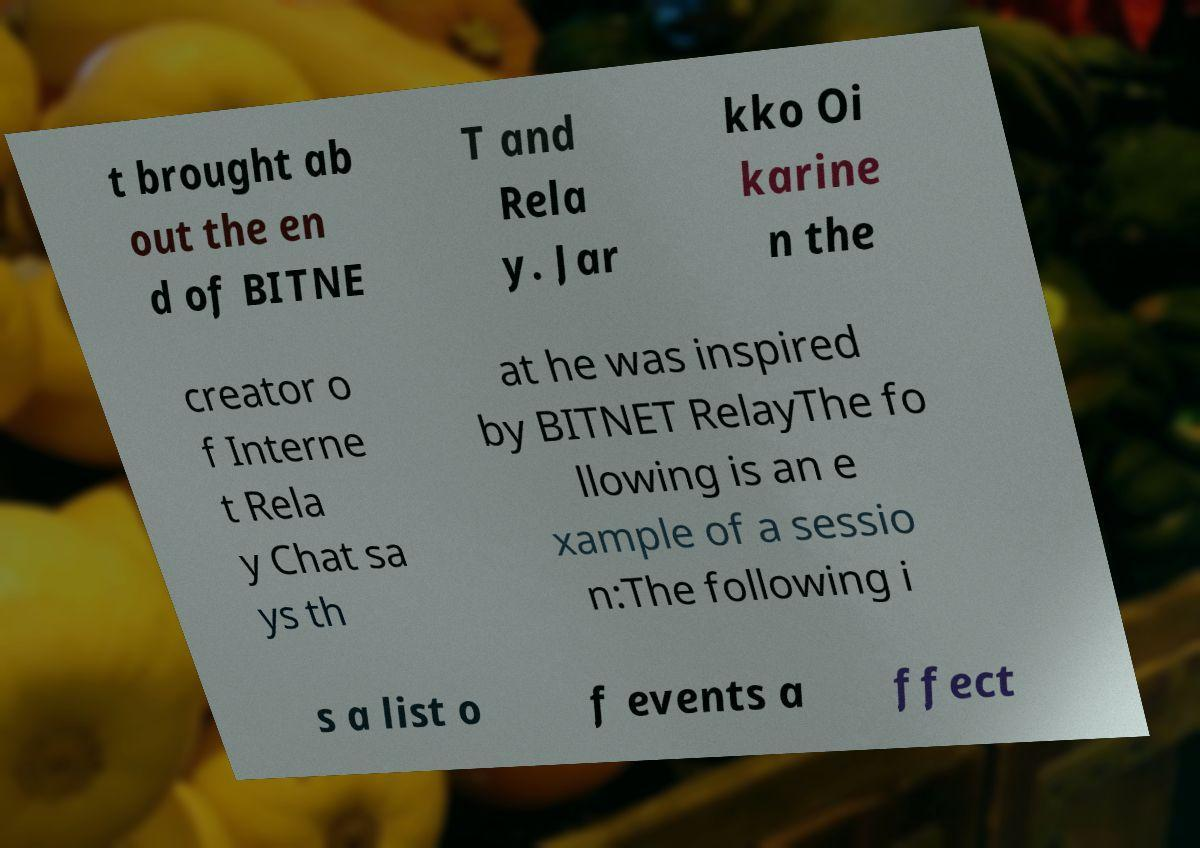There's text embedded in this image that I need extracted. Can you transcribe it verbatim? t brought ab out the en d of BITNE T and Rela y. Jar kko Oi karine n the creator o f Interne t Rela y Chat sa ys th at he was inspired by BITNET RelayThe fo llowing is an e xample of a sessio n:The following i s a list o f events a ffect 